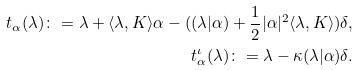Convert formula to latex. <formula><loc_0><loc_0><loc_500><loc_500>t _ { \alpha } ( \lambda ) \colon = \lambda + \langle \lambda , K \rangle \alpha - ( ( \lambda | \alpha ) + \frac { 1 } { 2 } | \alpha | ^ { 2 } \langle \lambda , K \rangle ) \delta , \\ t ^ { \iota } _ { \alpha } ( \lambda ) \colon = \lambda - \kappa ( \lambda | \alpha ) \delta .</formula> 